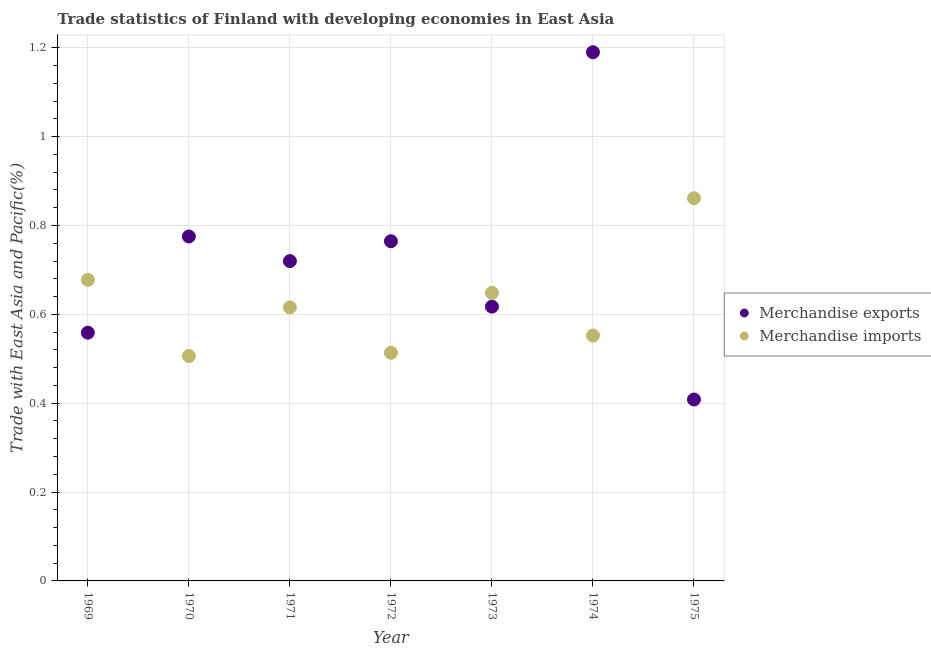How many different coloured dotlines are there?
Provide a succinct answer. 2. Is the number of dotlines equal to the number of legend labels?
Ensure brevity in your answer.  Yes. What is the merchandise exports in 1970?
Provide a short and direct response. 0.78. Across all years, what is the maximum merchandise imports?
Provide a short and direct response. 0.86. Across all years, what is the minimum merchandise imports?
Provide a succinct answer. 0.51. In which year was the merchandise imports maximum?
Your response must be concise. 1975. In which year was the merchandise imports minimum?
Make the answer very short. 1970. What is the total merchandise exports in the graph?
Give a very brief answer. 5.03. What is the difference between the merchandise imports in 1969 and that in 1970?
Provide a succinct answer. 0.17. What is the difference between the merchandise imports in 1969 and the merchandise exports in 1974?
Your answer should be compact. -0.51. What is the average merchandise imports per year?
Offer a terse response. 0.62. In the year 1975, what is the difference between the merchandise imports and merchandise exports?
Provide a succinct answer. 0.45. In how many years, is the merchandise imports greater than 0.32 %?
Offer a very short reply. 7. What is the ratio of the merchandise imports in 1970 to that in 1972?
Keep it short and to the point. 0.99. What is the difference between the highest and the second highest merchandise imports?
Your answer should be compact. 0.18. What is the difference between the highest and the lowest merchandise imports?
Provide a short and direct response. 0.36. In how many years, is the merchandise exports greater than the average merchandise exports taken over all years?
Provide a short and direct response. 4. Is the sum of the merchandise imports in 1971 and 1974 greater than the maximum merchandise exports across all years?
Make the answer very short. No. Does the merchandise exports monotonically increase over the years?
Offer a terse response. No. Is the merchandise exports strictly greater than the merchandise imports over the years?
Your response must be concise. No. How many dotlines are there?
Keep it short and to the point. 2. Does the graph contain any zero values?
Your response must be concise. No. How are the legend labels stacked?
Your response must be concise. Vertical. What is the title of the graph?
Your response must be concise. Trade statistics of Finland with developing economies in East Asia. Does "Secondary" appear as one of the legend labels in the graph?
Provide a succinct answer. No. What is the label or title of the Y-axis?
Offer a very short reply. Trade with East Asia and Pacific(%). What is the Trade with East Asia and Pacific(%) in Merchandise exports in 1969?
Give a very brief answer. 0.56. What is the Trade with East Asia and Pacific(%) in Merchandise imports in 1969?
Your answer should be very brief. 0.68. What is the Trade with East Asia and Pacific(%) in Merchandise exports in 1970?
Offer a very short reply. 0.78. What is the Trade with East Asia and Pacific(%) of Merchandise imports in 1970?
Make the answer very short. 0.51. What is the Trade with East Asia and Pacific(%) of Merchandise exports in 1971?
Provide a short and direct response. 0.72. What is the Trade with East Asia and Pacific(%) of Merchandise imports in 1971?
Offer a very short reply. 0.62. What is the Trade with East Asia and Pacific(%) in Merchandise exports in 1972?
Make the answer very short. 0.76. What is the Trade with East Asia and Pacific(%) of Merchandise imports in 1972?
Your response must be concise. 0.51. What is the Trade with East Asia and Pacific(%) of Merchandise exports in 1973?
Provide a short and direct response. 0.62. What is the Trade with East Asia and Pacific(%) in Merchandise imports in 1973?
Give a very brief answer. 0.65. What is the Trade with East Asia and Pacific(%) in Merchandise exports in 1974?
Give a very brief answer. 1.19. What is the Trade with East Asia and Pacific(%) in Merchandise imports in 1974?
Ensure brevity in your answer.  0.55. What is the Trade with East Asia and Pacific(%) in Merchandise exports in 1975?
Ensure brevity in your answer.  0.41. What is the Trade with East Asia and Pacific(%) in Merchandise imports in 1975?
Ensure brevity in your answer.  0.86. Across all years, what is the maximum Trade with East Asia and Pacific(%) in Merchandise exports?
Provide a short and direct response. 1.19. Across all years, what is the maximum Trade with East Asia and Pacific(%) in Merchandise imports?
Your response must be concise. 0.86. Across all years, what is the minimum Trade with East Asia and Pacific(%) of Merchandise exports?
Offer a terse response. 0.41. Across all years, what is the minimum Trade with East Asia and Pacific(%) of Merchandise imports?
Give a very brief answer. 0.51. What is the total Trade with East Asia and Pacific(%) of Merchandise exports in the graph?
Offer a terse response. 5.03. What is the total Trade with East Asia and Pacific(%) of Merchandise imports in the graph?
Provide a short and direct response. 4.38. What is the difference between the Trade with East Asia and Pacific(%) in Merchandise exports in 1969 and that in 1970?
Give a very brief answer. -0.22. What is the difference between the Trade with East Asia and Pacific(%) of Merchandise imports in 1969 and that in 1970?
Offer a very short reply. 0.17. What is the difference between the Trade with East Asia and Pacific(%) of Merchandise exports in 1969 and that in 1971?
Make the answer very short. -0.16. What is the difference between the Trade with East Asia and Pacific(%) in Merchandise imports in 1969 and that in 1971?
Offer a terse response. 0.06. What is the difference between the Trade with East Asia and Pacific(%) in Merchandise exports in 1969 and that in 1972?
Give a very brief answer. -0.21. What is the difference between the Trade with East Asia and Pacific(%) of Merchandise imports in 1969 and that in 1972?
Provide a succinct answer. 0.16. What is the difference between the Trade with East Asia and Pacific(%) in Merchandise exports in 1969 and that in 1973?
Offer a terse response. -0.06. What is the difference between the Trade with East Asia and Pacific(%) in Merchandise imports in 1969 and that in 1973?
Your response must be concise. 0.03. What is the difference between the Trade with East Asia and Pacific(%) in Merchandise exports in 1969 and that in 1974?
Provide a short and direct response. -0.63. What is the difference between the Trade with East Asia and Pacific(%) in Merchandise imports in 1969 and that in 1974?
Keep it short and to the point. 0.13. What is the difference between the Trade with East Asia and Pacific(%) in Merchandise exports in 1969 and that in 1975?
Keep it short and to the point. 0.15. What is the difference between the Trade with East Asia and Pacific(%) in Merchandise imports in 1969 and that in 1975?
Make the answer very short. -0.18. What is the difference between the Trade with East Asia and Pacific(%) of Merchandise exports in 1970 and that in 1971?
Make the answer very short. 0.06. What is the difference between the Trade with East Asia and Pacific(%) of Merchandise imports in 1970 and that in 1971?
Provide a succinct answer. -0.11. What is the difference between the Trade with East Asia and Pacific(%) of Merchandise exports in 1970 and that in 1972?
Ensure brevity in your answer.  0.01. What is the difference between the Trade with East Asia and Pacific(%) of Merchandise imports in 1970 and that in 1972?
Your answer should be very brief. -0.01. What is the difference between the Trade with East Asia and Pacific(%) of Merchandise exports in 1970 and that in 1973?
Make the answer very short. 0.16. What is the difference between the Trade with East Asia and Pacific(%) in Merchandise imports in 1970 and that in 1973?
Offer a very short reply. -0.14. What is the difference between the Trade with East Asia and Pacific(%) in Merchandise exports in 1970 and that in 1974?
Make the answer very short. -0.41. What is the difference between the Trade with East Asia and Pacific(%) of Merchandise imports in 1970 and that in 1974?
Your answer should be very brief. -0.05. What is the difference between the Trade with East Asia and Pacific(%) of Merchandise exports in 1970 and that in 1975?
Your response must be concise. 0.37. What is the difference between the Trade with East Asia and Pacific(%) in Merchandise imports in 1970 and that in 1975?
Your response must be concise. -0.36. What is the difference between the Trade with East Asia and Pacific(%) of Merchandise exports in 1971 and that in 1972?
Offer a terse response. -0.04. What is the difference between the Trade with East Asia and Pacific(%) in Merchandise imports in 1971 and that in 1972?
Your answer should be compact. 0.1. What is the difference between the Trade with East Asia and Pacific(%) in Merchandise exports in 1971 and that in 1973?
Give a very brief answer. 0.1. What is the difference between the Trade with East Asia and Pacific(%) of Merchandise imports in 1971 and that in 1973?
Offer a very short reply. -0.03. What is the difference between the Trade with East Asia and Pacific(%) in Merchandise exports in 1971 and that in 1974?
Ensure brevity in your answer.  -0.47. What is the difference between the Trade with East Asia and Pacific(%) in Merchandise imports in 1971 and that in 1974?
Keep it short and to the point. 0.06. What is the difference between the Trade with East Asia and Pacific(%) of Merchandise exports in 1971 and that in 1975?
Ensure brevity in your answer.  0.31. What is the difference between the Trade with East Asia and Pacific(%) in Merchandise imports in 1971 and that in 1975?
Offer a very short reply. -0.25. What is the difference between the Trade with East Asia and Pacific(%) in Merchandise exports in 1972 and that in 1973?
Keep it short and to the point. 0.15. What is the difference between the Trade with East Asia and Pacific(%) of Merchandise imports in 1972 and that in 1973?
Provide a succinct answer. -0.13. What is the difference between the Trade with East Asia and Pacific(%) of Merchandise exports in 1972 and that in 1974?
Offer a very short reply. -0.43. What is the difference between the Trade with East Asia and Pacific(%) of Merchandise imports in 1972 and that in 1974?
Provide a short and direct response. -0.04. What is the difference between the Trade with East Asia and Pacific(%) of Merchandise exports in 1972 and that in 1975?
Your answer should be compact. 0.36. What is the difference between the Trade with East Asia and Pacific(%) of Merchandise imports in 1972 and that in 1975?
Keep it short and to the point. -0.35. What is the difference between the Trade with East Asia and Pacific(%) in Merchandise exports in 1973 and that in 1974?
Your answer should be very brief. -0.57. What is the difference between the Trade with East Asia and Pacific(%) in Merchandise imports in 1973 and that in 1974?
Make the answer very short. 0.1. What is the difference between the Trade with East Asia and Pacific(%) of Merchandise exports in 1973 and that in 1975?
Provide a succinct answer. 0.21. What is the difference between the Trade with East Asia and Pacific(%) of Merchandise imports in 1973 and that in 1975?
Offer a terse response. -0.21. What is the difference between the Trade with East Asia and Pacific(%) in Merchandise exports in 1974 and that in 1975?
Offer a very short reply. 0.78. What is the difference between the Trade with East Asia and Pacific(%) in Merchandise imports in 1974 and that in 1975?
Provide a succinct answer. -0.31. What is the difference between the Trade with East Asia and Pacific(%) in Merchandise exports in 1969 and the Trade with East Asia and Pacific(%) in Merchandise imports in 1970?
Your answer should be very brief. 0.05. What is the difference between the Trade with East Asia and Pacific(%) in Merchandise exports in 1969 and the Trade with East Asia and Pacific(%) in Merchandise imports in 1971?
Ensure brevity in your answer.  -0.06. What is the difference between the Trade with East Asia and Pacific(%) in Merchandise exports in 1969 and the Trade with East Asia and Pacific(%) in Merchandise imports in 1972?
Offer a very short reply. 0.05. What is the difference between the Trade with East Asia and Pacific(%) of Merchandise exports in 1969 and the Trade with East Asia and Pacific(%) of Merchandise imports in 1973?
Ensure brevity in your answer.  -0.09. What is the difference between the Trade with East Asia and Pacific(%) in Merchandise exports in 1969 and the Trade with East Asia and Pacific(%) in Merchandise imports in 1974?
Provide a succinct answer. 0.01. What is the difference between the Trade with East Asia and Pacific(%) in Merchandise exports in 1969 and the Trade with East Asia and Pacific(%) in Merchandise imports in 1975?
Make the answer very short. -0.3. What is the difference between the Trade with East Asia and Pacific(%) of Merchandise exports in 1970 and the Trade with East Asia and Pacific(%) of Merchandise imports in 1971?
Your response must be concise. 0.16. What is the difference between the Trade with East Asia and Pacific(%) of Merchandise exports in 1970 and the Trade with East Asia and Pacific(%) of Merchandise imports in 1972?
Provide a succinct answer. 0.26. What is the difference between the Trade with East Asia and Pacific(%) of Merchandise exports in 1970 and the Trade with East Asia and Pacific(%) of Merchandise imports in 1973?
Provide a short and direct response. 0.13. What is the difference between the Trade with East Asia and Pacific(%) in Merchandise exports in 1970 and the Trade with East Asia and Pacific(%) in Merchandise imports in 1974?
Provide a succinct answer. 0.22. What is the difference between the Trade with East Asia and Pacific(%) in Merchandise exports in 1970 and the Trade with East Asia and Pacific(%) in Merchandise imports in 1975?
Provide a short and direct response. -0.09. What is the difference between the Trade with East Asia and Pacific(%) in Merchandise exports in 1971 and the Trade with East Asia and Pacific(%) in Merchandise imports in 1972?
Ensure brevity in your answer.  0.21. What is the difference between the Trade with East Asia and Pacific(%) in Merchandise exports in 1971 and the Trade with East Asia and Pacific(%) in Merchandise imports in 1973?
Offer a very short reply. 0.07. What is the difference between the Trade with East Asia and Pacific(%) in Merchandise exports in 1971 and the Trade with East Asia and Pacific(%) in Merchandise imports in 1974?
Keep it short and to the point. 0.17. What is the difference between the Trade with East Asia and Pacific(%) of Merchandise exports in 1971 and the Trade with East Asia and Pacific(%) of Merchandise imports in 1975?
Offer a terse response. -0.14. What is the difference between the Trade with East Asia and Pacific(%) of Merchandise exports in 1972 and the Trade with East Asia and Pacific(%) of Merchandise imports in 1973?
Offer a terse response. 0.12. What is the difference between the Trade with East Asia and Pacific(%) of Merchandise exports in 1972 and the Trade with East Asia and Pacific(%) of Merchandise imports in 1974?
Ensure brevity in your answer.  0.21. What is the difference between the Trade with East Asia and Pacific(%) of Merchandise exports in 1972 and the Trade with East Asia and Pacific(%) of Merchandise imports in 1975?
Your response must be concise. -0.1. What is the difference between the Trade with East Asia and Pacific(%) of Merchandise exports in 1973 and the Trade with East Asia and Pacific(%) of Merchandise imports in 1974?
Your answer should be very brief. 0.07. What is the difference between the Trade with East Asia and Pacific(%) in Merchandise exports in 1973 and the Trade with East Asia and Pacific(%) in Merchandise imports in 1975?
Give a very brief answer. -0.24. What is the difference between the Trade with East Asia and Pacific(%) in Merchandise exports in 1974 and the Trade with East Asia and Pacific(%) in Merchandise imports in 1975?
Keep it short and to the point. 0.33. What is the average Trade with East Asia and Pacific(%) in Merchandise exports per year?
Offer a terse response. 0.72. In the year 1969, what is the difference between the Trade with East Asia and Pacific(%) in Merchandise exports and Trade with East Asia and Pacific(%) in Merchandise imports?
Provide a short and direct response. -0.12. In the year 1970, what is the difference between the Trade with East Asia and Pacific(%) of Merchandise exports and Trade with East Asia and Pacific(%) of Merchandise imports?
Your response must be concise. 0.27. In the year 1971, what is the difference between the Trade with East Asia and Pacific(%) in Merchandise exports and Trade with East Asia and Pacific(%) in Merchandise imports?
Give a very brief answer. 0.1. In the year 1972, what is the difference between the Trade with East Asia and Pacific(%) of Merchandise exports and Trade with East Asia and Pacific(%) of Merchandise imports?
Offer a terse response. 0.25. In the year 1973, what is the difference between the Trade with East Asia and Pacific(%) of Merchandise exports and Trade with East Asia and Pacific(%) of Merchandise imports?
Your response must be concise. -0.03. In the year 1974, what is the difference between the Trade with East Asia and Pacific(%) of Merchandise exports and Trade with East Asia and Pacific(%) of Merchandise imports?
Offer a very short reply. 0.64. In the year 1975, what is the difference between the Trade with East Asia and Pacific(%) of Merchandise exports and Trade with East Asia and Pacific(%) of Merchandise imports?
Give a very brief answer. -0.45. What is the ratio of the Trade with East Asia and Pacific(%) of Merchandise exports in 1969 to that in 1970?
Offer a very short reply. 0.72. What is the ratio of the Trade with East Asia and Pacific(%) in Merchandise imports in 1969 to that in 1970?
Give a very brief answer. 1.34. What is the ratio of the Trade with East Asia and Pacific(%) in Merchandise exports in 1969 to that in 1971?
Your answer should be very brief. 0.78. What is the ratio of the Trade with East Asia and Pacific(%) in Merchandise imports in 1969 to that in 1971?
Your answer should be very brief. 1.1. What is the ratio of the Trade with East Asia and Pacific(%) of Merchandise exports in 1969 to that in 1972?
Give a very brief answer. 0.73. What is the ratio of the Trade with East Asia and Pacific(%) of Merchandise imports in 1969 to that in 1972?
Offer a very short reply. 1.32. What is the ratio of the Trade with East Asia and Pacific(%) of Merchandise exports in 1969 to that in 1973?
Your answer should be compact. 0.91. What is the ratio of the Trade with East Asia and Pacific(%) in Merchandise imports in 1969 to that in 1973?
Offer a very short reply. 1.05. What is the ratio of the Trade with East Asia and Pacific(%) in Merchandise exports in 1969 to that in 1974?
Your response must be concise. 0.47. What is the ratio of the Trade with East Asia and Pacific(%) in Merchandise imports in 1969 to that in 1974?
Give a very brief answer. 1.23. What is the ratio of the Trade with East Asia and Pacific(%) in Merchandise exports in 1969 to that in 1975?
Give a very brief answer. 1.37. What is the ratio of the Trade with East Asia and Pacific(%) of Merchandise imports in 1969 to that in 1975?
Offer a very short reply. 0.79. What is the ratio of the Trade with East Asia and Pacific(%) of Merchandise exports in 1970 to that in 1971?
Give a very brief answer. 1.08. What is the ratio of the Trade with East Asia and Pacific(%) in Merchandise imports in 1970 to that in 1971?
Offer a very short reply. 0.82. What is the ratio of the Trade with East Asia and Pacific(%) of Merchandise exports in 1970 to that in 1972?
Provide a short and direct response. 1.01. What is the ratio of the Trade with East Asia and Pacific(%) in Merchandise imports in 1970 to that in 1972?
Ensure brevity in your answer.  0.99. What is the ratio of the Trade with East Asia and Pacific(%) in Merchandise exports in 1970 to that in 1973?
Your answer should be very brief. 1.26. What is the ratio of the Trade with East Asia and Pacific(%) in Merchandise imports in 1970 to that in 1973?
Make the answer very short. 0.78. What is the ratio of the Trade with East Asia and Pacific(%) of Merchandise exports in 1970 to that in 1974?
Make the answer very short. 0.65. What is the ratio of the Trade with East Asia and Pacific(%) in Merchandise imports in 1970 to that in 1974?
Make the answer very short. 0.92. What is the ratio of the Trade with East Asia and Pacific(%) of Merchandise exports in 1970 to that in 1975?
Offer a very short reply. 1.9. What is the ratio of the Trade with East Asia and Pacific(%) of Merchandise imports in 1970 to that in 1975?
Your response must be concise. 0.59. What is the ratio of the Trade with East Asia and Pacific(%) in Merchandise exports in 1971 to that in 1972?
Make the answer very short. 0.94. What is the ratio of the Trade with East Asia and Pacific(%) of Merchandise imports in 1971 to that in 1972?
Make the answer very short. 1.2. What is the ratio of the Trade with East Asia and Pacific(%) of Merchandise exports in 1971 to that in 1973?
Your response must be concise. 1.17. What is the ratio of the Trade with East Asia and Pacific(%) in Merchandise imports in 1971 to that in 1973?
Make the answer very short. 0.95. What is the ratio of the Trade with East Asia and Pacific(%) in Merchandise exports in 1971 to that in 1974?
Keep it short and to the point. 0.6. What is the ratio of the Trade with East Asia and Pacific(%) in Merchandise imports in 1971 to that in 1974?
Offer a terse response. 1.11. What is the ratio of the Trade with East Asia and Pacific(%) of Merchandise exports in 1971 to that in 1975?
Provide a short and direct response. 1.76. What is the ratio of the Trade with East Asia and Pacific(%) in Merchandise imports in 1971 to that in 1975?
Offer a very short reply. 0.71. What is the ratio of the Trade with East Asia and Pacific(%) of Merchandise exports in 1972 to that in 1973?
Make the answer very short. 1.24. What is the ratio of the Trade with East Asia and Pacific(%) in Merchandise imports in 1972 to that in 1973?
Your response must be concise. 0.79. What is the ratio of the Trade with East Asia and Pacific(%) of Merchandise exports in 1972 to that in 1974?
Give a very brief answer. 0.64. What is the ratio of the Trade with East Asia and Pacific(%) of Merchandise imports in 1972 to that in 1974?
Offer a very short reply. 0.93. What is the ratio of the Trade with East Asia and Pacific(%) in Merchandise exports in 1972 to that in 1975?
Keep it short and to the point. 1.87. What is the ratio of the Trade with East Asia and Pacific(%) in Merchandise imports in 1972 to that in 1975?
Your answer should be very brief. 0.6. What is the ratio of the Trade with East Asia and Pacific(%) in Merchandise exports in 1973 to that in 1974?
Provide a short and direct response. 0.52. What is the ratio of the Trade with East Asia and Pacific(%) in Merchandise imports in 1973 to that in 1974?
Make the answer very short. 1.17. What is the ratio of the Trade with East Asia and Pacific(%) in Merchandise exports in 1973 to that in 1975?
Keep it short and to the point. 1.51. What is the ratio of the Trade with East Asia and Pacific(%) in Merchandise imports in 1973 to that in 1975?
Offer a very short reply. 0.75. What is the ratio of the Trade with East Asia and Pacific(%) of Merchandise exports in 1974 to that in 1975?
Your response must be concise. 2.91. What is the ratio of the Trade with East Asia and Pacific(%) of Merchandise imports in 1974 to that in 1975?
Provide a short and direct response. 0.64. What is the difference between the highest and the second highest Trade with East Asia and Pacific(%) in Merchandise exports?
Offer a terse response. 0.41. What is the difference between the highest and the second highest Trade with East Asia and Pacific(%) of Merchandise imports?
Keep it short and to the point. 0.18. What is the difference between the highest and the lowest Trade with East Asia and Pacific(%) in Merchandise exports?
Your response must be concise. 0.78. What is the difference between the highest and the lowest Trade with East Asia and Pacific(%) of Merchandise imports?
Keep it short and to the point. 0.36. 